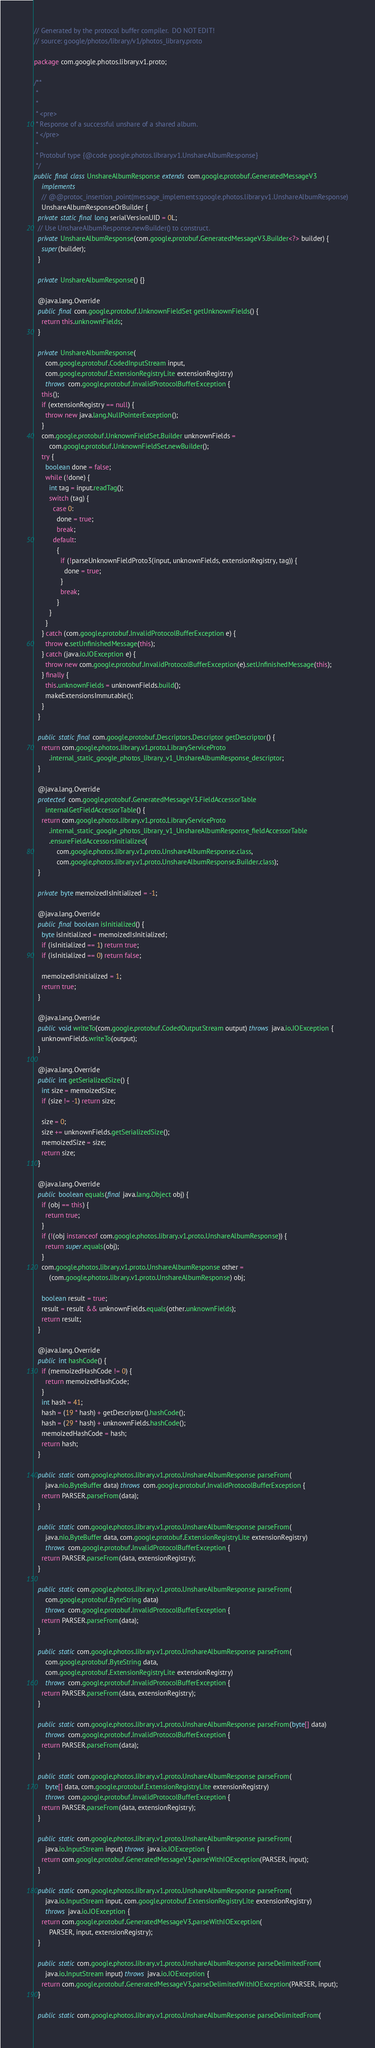<code> <loc_0><loc_0><loc_500><loc_500><_Java_>// Generated by the protocol buffer compiler.  DO NOT EDIT!
// source: google/photos/library/v1/photos_library.proto

package com.google.photos.library.v1.proto;

/**
 *
 *
 * <pre>
 * Response of a successful unshare of a shared album.
 * </pre>
 *
 * Protobuf type {@code google.photos.library.v1.UnshareAlbumResponse}
 */
public final class UnshareAlbumResponse extends com.google.protobuf.GeneratedMessageV3
    implements
    // @@protoc_insertion_point(message_implements:google.photos.library.v1.UnshareAlbumResponse)
    UnshareAlbumResponseOrBuilder {
  private static final long serialVersionUID = 0L;
  // Use UnshareAlbumResponse.newBuilder() to construct.
  private UnshareAlbumResponse(com.google.protobuf.GeneratedMessageV3.Builder<?> builder) {
    super(builder);
  }

  private UnshareAlbumResponse() {}

  @java.lang.Override
  public final com.google.protobuf.UnknownFieldSet getUnknownFields() {
    return this.unknownFields;
  }

  private UnshareAlbumResponse(
      com.google.protobuf.CodedInputStream input,
      com.google.protobuf.ExtensionRegistryLite extensionRegistry)
      throws com.google.protobuf.InvalidProtocolBufferException {
    this();
    if (extensionRegistry == null) {
      throw new java.lang.NullPointerException();
    }
    com.google.protobuf.UnknownFieldSet.Builder unknownFields =
        com.google.protobuf.UnknownFieldSet.newBuilder();
    try {
      boolean done = false;
      while (!done) {
        int tag = input.readTag();
        switch (tag) {
          case 0:
            done = true;
            break;
          default:
            {
              if (!parseUnknownFieldProto3(input, unknownFields, extensionRegistry, tag)) {
                done = true;
              }
              break;
            }
        }
      }
    } catch (com.google.protobuf.InvalidProtocolBufferException e) {
      throw e.setUnfinishedMessage(this);
    } catch (java.io.IOException e) {
      throw new com.google.protobuf.InvalidProtocolBufferException(e).setUnfinishedMessage(this);
    } finally {
      this.unknownFields = unknownFields.build();
      makeExtensionsImmutable();
    }
  }

  public static final com.google.protobuf.Descriptors.Descriptor getDescriptor() {
    return com.google.photos.library.v1.proto.LibraryServiceProto
        .internal_static_google_photos_library_v1_UnshareAlbumResponse_descriptor;
  }

  @java.lang.Override
  protected com.google.protobuf.GeneratedMessageV3.FieldAccessorTable
      internalGetFieldAccessorTable() {
    return com.google.photos.library.v1.proto.LibraryServiceProto
        .internal_static_google_photos_library_v1_UnshareAlbumResponse_fieldAccessorTable
        .ensureFieldAccessorsInitialized(
            com.google.photos.library.v1.proto.UnshareAlbumResponse.class,
            com.google.photos.library.v1.proto.UnshareAlbumResponse.Builder.class);
  }

  private byte memoizedIsInitialized = -1;

  @java.lang.Override
  public final boolean isInitialized() {
    byte isInitialized = memoizedIsInitialized;
    if (isInitialized == 1) return true;
    if (isInitialized == 0) return false;

    memoizedIsInitialized = 1;
    return true;
  }

  @java.lang.Override
  public void writeTo(com.google.protobuf.CodedOutputStream output) throws java.io.IOException {
    unknownFields.writeTo(output);
  }

  @java.lang.Override
  public int getSerializedSize() {
    int size = memoizedSize;
    if (size != -1) return size;

    size = 0;
    size += unknownFields.getSerializedSize();
    memoizedSize = size;
    return size;
  }

  @java.lang.Override
  public boolean equals(final java.lang.Object obj) {
    if (obj == this) {
      return true;
    }
    if (!(obj instanceof com.google.photos.library.v1.proto.UnshareAlbumResponse)) {
      return super.equals(obj);
    }
    com.google.photos.library.v1.proto.UnshareAlbumResponse other =
        (com.google.photos.library.v1.proto.UnshareAlbumResponse) obj;

    boolean result = true;
    result = result && unknownFields.equals(other.unknownFields);
    return result;
  }

  @java.lang.Override
  public int hashCode() {
    if (memoizedHashCode != 0) {
      return memoizedHashCode;
    }
    int hash = 41;
    hash = (19 * hash) + getDescriptor().hashCode();
    hash = (29 * hash) + unknownFields.hashCode();
    memoizedHashCode = hash;
    return hash;
  }

  public static com.google.photos.library.v1.proto.UnshareAlbumResponse parseFrom(
      java.nio.ByteBuffer data) throws com.google.protobuf.InvalidProtocolBufferException {
    return PARSER.parseFrom(data);
  }

  public static com.google.photos.library.v1.proto.UnshareAlbumResponse parseFrom(
      java.nio.ByteBuffer data, com.google.protobuf.ExtensionRegistryLite extensionRegistry)
      throws com.google.protobuf.InvalidProtocolBufferException {
    return PARSER.parseFrom(data, extensionRegistry);
  }

  public static com.google.photos.library.v1.proto.UnshareAlbumResponse parseFrom(
      com.google.protobuf.ByteString data)
      throws com.google.protobuf.InvalidProtocolBufferException {
    return PARSER.parseFrom(data);
  }

  public static com.google.photos.library.v1.proto.UnshareAlbumResponse parseFrom(
      com.google.protobuf.ByteString data,
      com.google.protobuf.ExtensionRegistryLite extensionRegistry)
      throws com.google.protobuf.InvalidProtocolBufferException {
    return PARSER.parseFrom(data, extensionRegistry);
  }

  public static com.google.photos.library.v1.proto.UnshareAlbumResponse parseFrom(byte[] data)
      throws com.google.protobuf.InvalidProtocolBufferException {
    return PARSER.parseFrom(data);
  }

  public static com.google.photos.library.v1.proto.UnshareAlbumResponse parseFrom(
      byte[] data, com.google.protobuf.ExtensionRegistryLite extensionRegistry)
      throws com.google.protobuf.InvalidProtocolBufferException {
    return PARSER.parseFrom(data, extensionRegistry);
  }

  public static com.google.photos.library.v1.proto.UnshareAlbumResponse parseFrom(
      java.io.InputStream input) throws java.io.IOException {
    return com.google.protobuf.GeneratedMessageV3.parseWithIOException(PARSER, input);
  }

  public static com.google.photos.library.v1.proto.UnshareAlbumResponse parseFrom(
      java.io.InputStream input, com.google.protobuf.ExtensionRegistryLite extensionRegistry)
      throws java.io.IOException {
    return com.google.protobuf.GeneratedMessageV3.parseWithIOException(
        PARSER, input, extensionRegistry);
  }

  public static com.google.photos.library.v1.proto.UnshareAlbumResponse parseDelimitedFrom(
      java.io.InputStream input) throws java.io.IOException {
    return com.google.protobuf.GeneratedMessageV3.parseDelimitedWithIOException(PARSER, input);
  }

  public static com.google.photos.library.v1.proto.UnshareAlbumResponse parseDelimitedFrom(</code> 